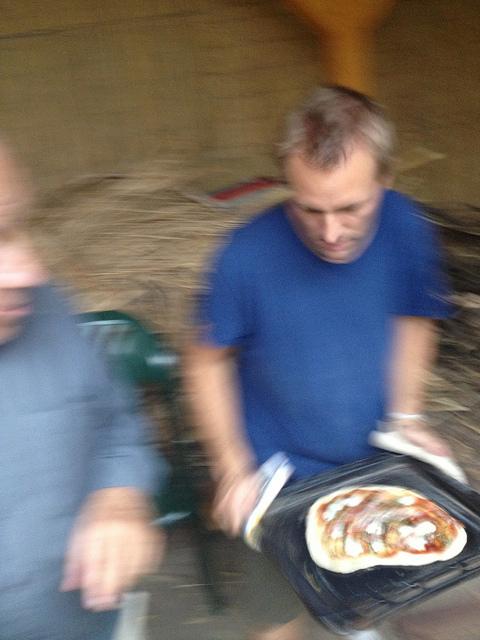What is the guy holding?
Quick response, please. Pizza. What type of shirt is the guy wearing?
Write a very short answer. T shirt. How many people are in the picture?
Keep it brief. 2. 